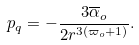Convert formula to latex. <formula><loc_0><loc_0><loc_500><loc_500>p _ { q } = - \frac { 3 \overline { \alpha } _ { o } } { 2 r ^ { 3 ( \varpi _ { o } + 1 ) } } .</formula> 